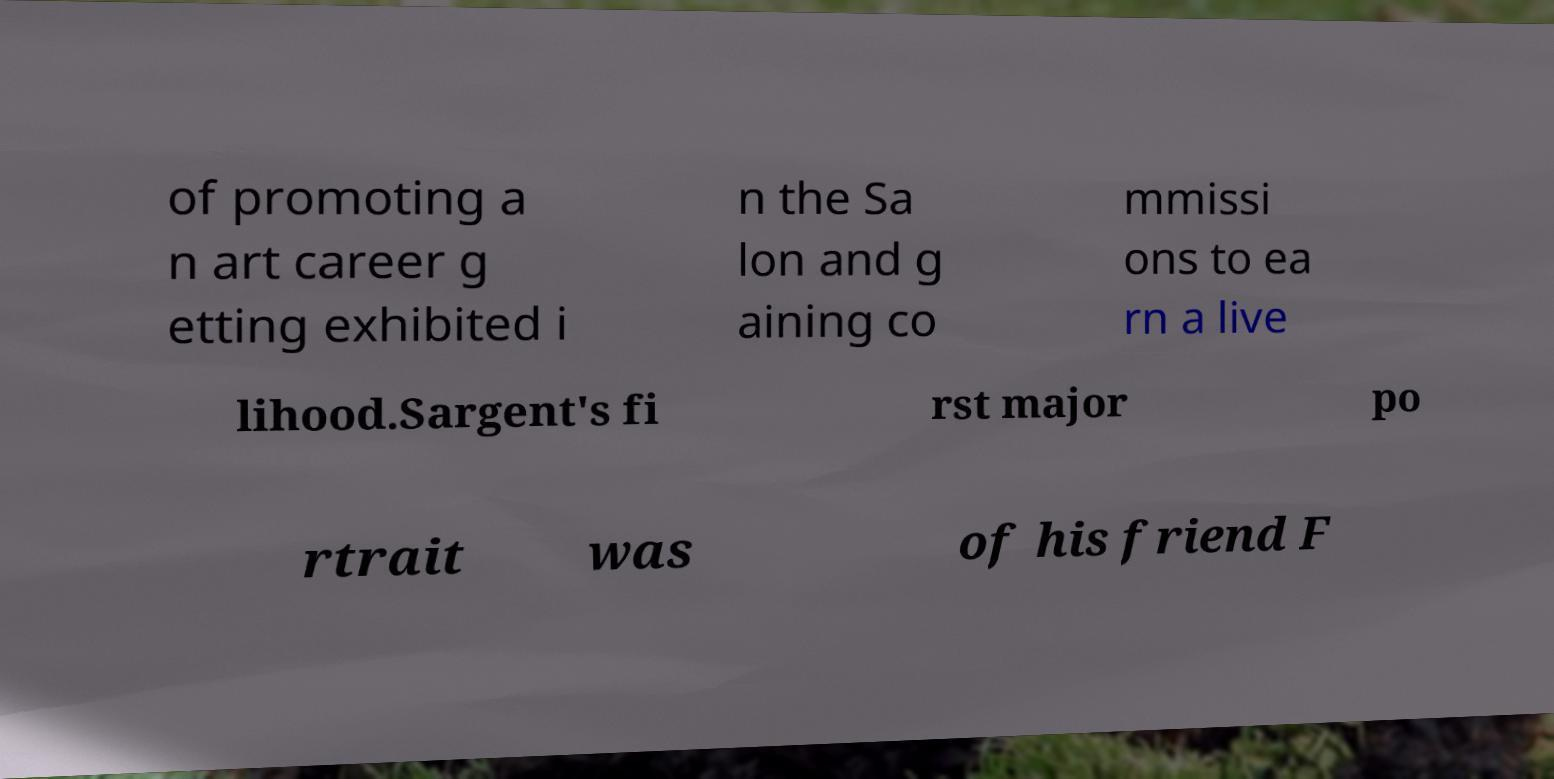I need the written content from this picture converted into text. Can you do that? of promoting a n art career g etting exhibited i n the Sa lon and g aining co mmissi ons to ea rn a live lihood.Sargent's fi rst major po rtrait was of his friend F 